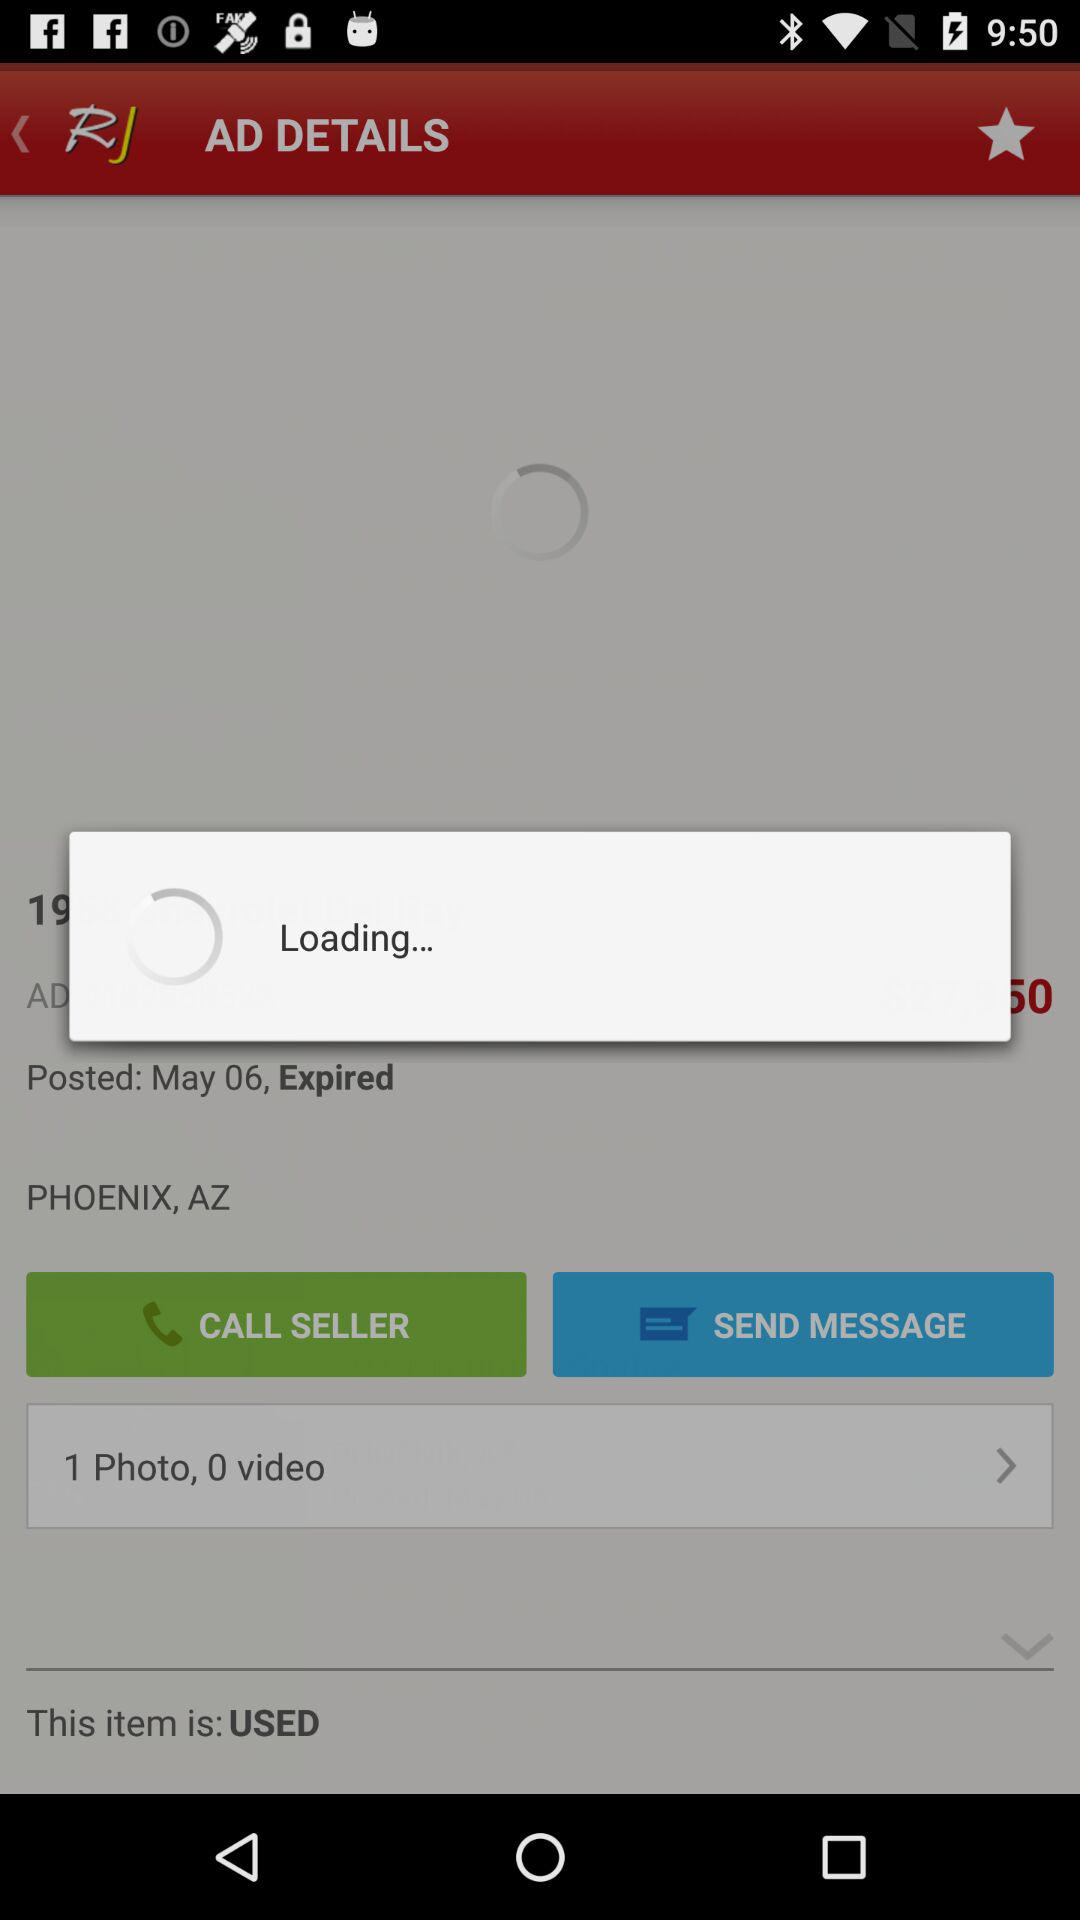What is the number of photos? The number of photos is 1. 